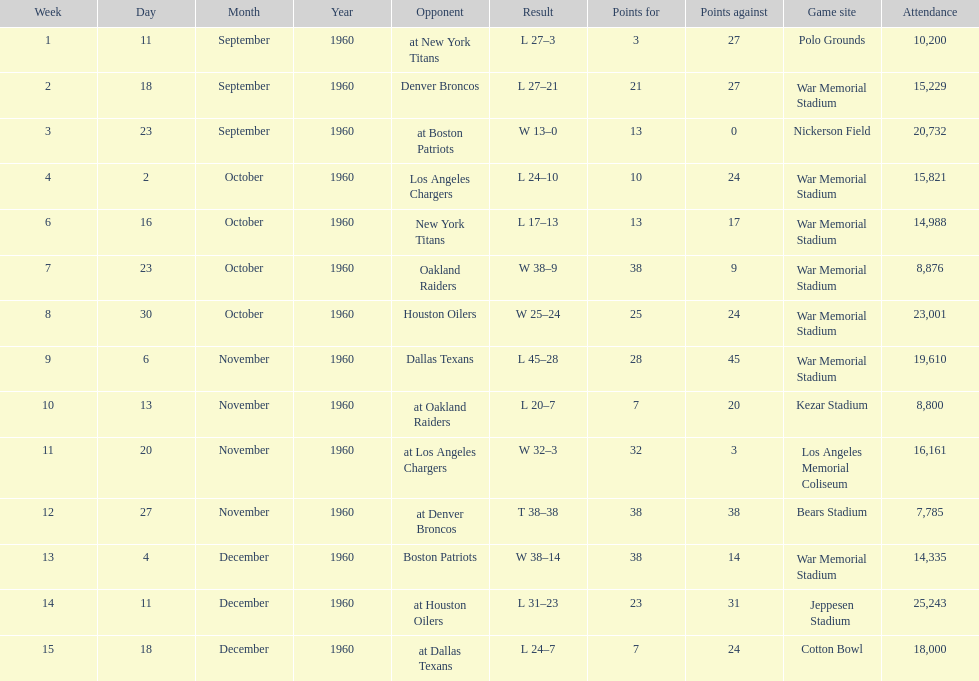What were the total number of games played in november? 4. Could you parse the entire table? {'header': ['Week', 'Day', 'Month', 'Year', 'Opponent', 'Result', 'Points for', 'Points against', 'Game site', 'Attendance'], 'rows': [['1', '11', 'September', '1960', 'at New York Titans', 'L 27–3', '3', '27', 'Polo Grounds', '10,200'], ['2', '18', 'September', '1960', 'Denver Broncos', 'L 27–21', '21', '27', 'War Memorial Stadium', '15,229'], ['3', '23', 'September', '1960', 'at Boston Patriots', 'W 13–0', '13', '0', 'Nickerson Field', '20,732'], ['4', '2', 'October', '1960', 'Los Angeles Chargers', 'L 24–10', '10', '24', 'War Memorial Stadium', '15,821'], ['6', '16', 'October', '1960', 'New York Titans', 'L 17–13', '13', '17', 'War Memorial Stadium', '14,988'], ['7', '23', 'October', '1960', 'Oakland Raiders', 'W 38–9', '38', '9', 'War Memorial Stadium', '8,876'], ['8', '30', 'October', '1960', 'Houston Oilers', 'W 25–24', '25', '24', 'War Memorial Stadium', '23,001'], ['9', '6', 'November', '1960', 'Dallas Texans', 'L 45–28', '28', '45', 'War Memorial Stadium', '19,610'], ['10', '13', 'November', '1960', 'at Oakland Raiders', 'L 20–7', '7', '20', 'Kezar Stadium', '8,800'], ['11', '20', 'November', '1960', 'at Los Angeles Chargers', 'W 32–3', '32', '3', 'Los Angeles Memorial Coliseum', '16,161'], ['12', '27', 'November', '1960', 'at Denver Broncos', 'T 38–38', '38', '38', 'Bears Stadium', '7,785'], ['13', '4', 'December', '1960', 'Boston Patriots', 'W 38–14', '38', '14', 'War Memorial Stadium', '14,335'], ['14', '11', 'December', '1960', 'at Houston Oilers', 'L 31–23', '23', '31', 'Jeppesen Stadium', '25,243'], ['15', '18', 'December', '1960', 'at Dallas Texans', 'L 24–7', '7', '24', 'Cotton Bowl', '18,000']]} 